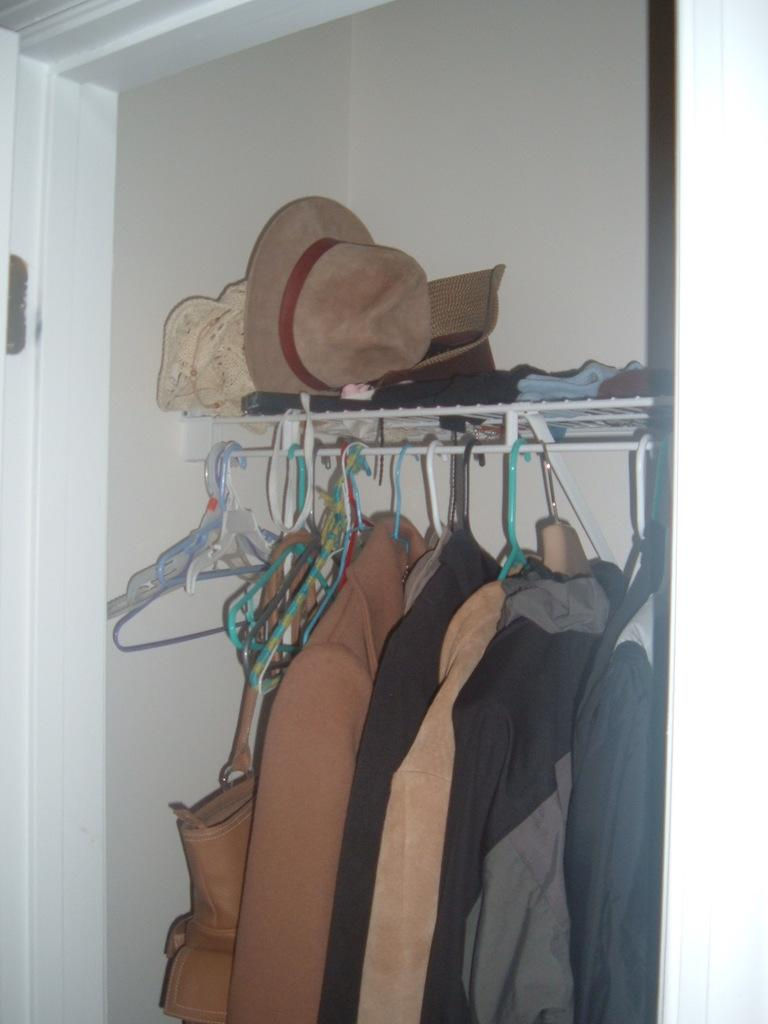What type of items can be seen in the image? There are clothes, hangers, a bag, and hats in the image. What might be used to hang the clothes and hats? There are hangers in the image that might be used to hang the clothes and hats. What else is present in the image besides the clothes and hangers? There is a bag in the image. Can you tell me how many hooks are visible in the image? There is no mention of hooks in the provided facts, so it cannot be determined from the image. What type of haircut is being given to the person in the image? There is no person or haircut present in the image; it features clothes, hangers, a bag, and hats. What type of collar is visible on the clothes in the image? There is no specific mention of a collar on the clothes in the image, so it cannot be determined from the image. 